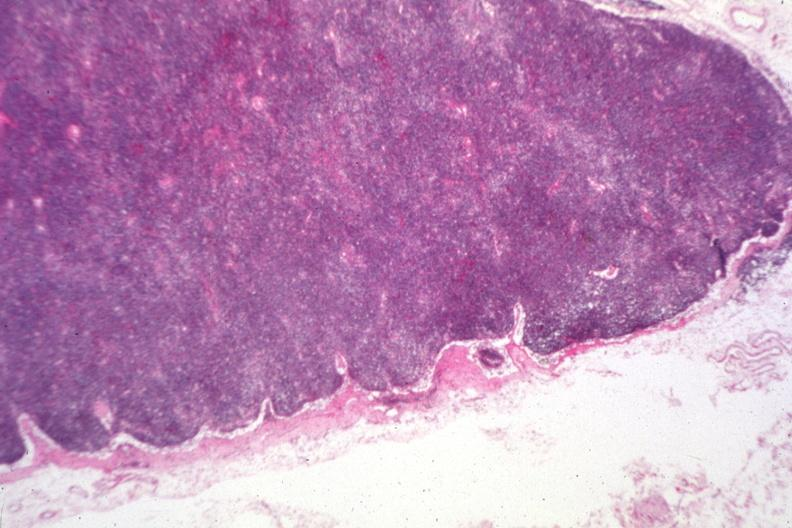s chronic lymphocytic leukemia present?
Answer the question using a single word or phrase. Yes 